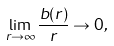<formula> <loc_0><loc_0><loc_500><loc_500>\lim _ { r \to \infty } \frac { b ( r ) } { r } \rightarrow 0 ,</formula> 